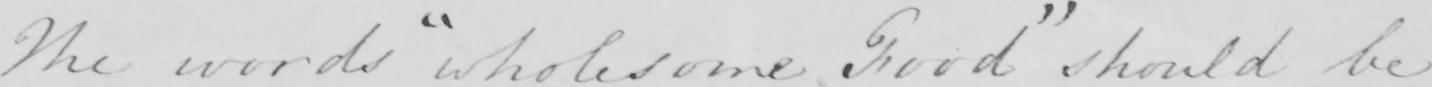Transcribe the text shown in this historical manuscript line. The words  " wholesome Food "  should be 